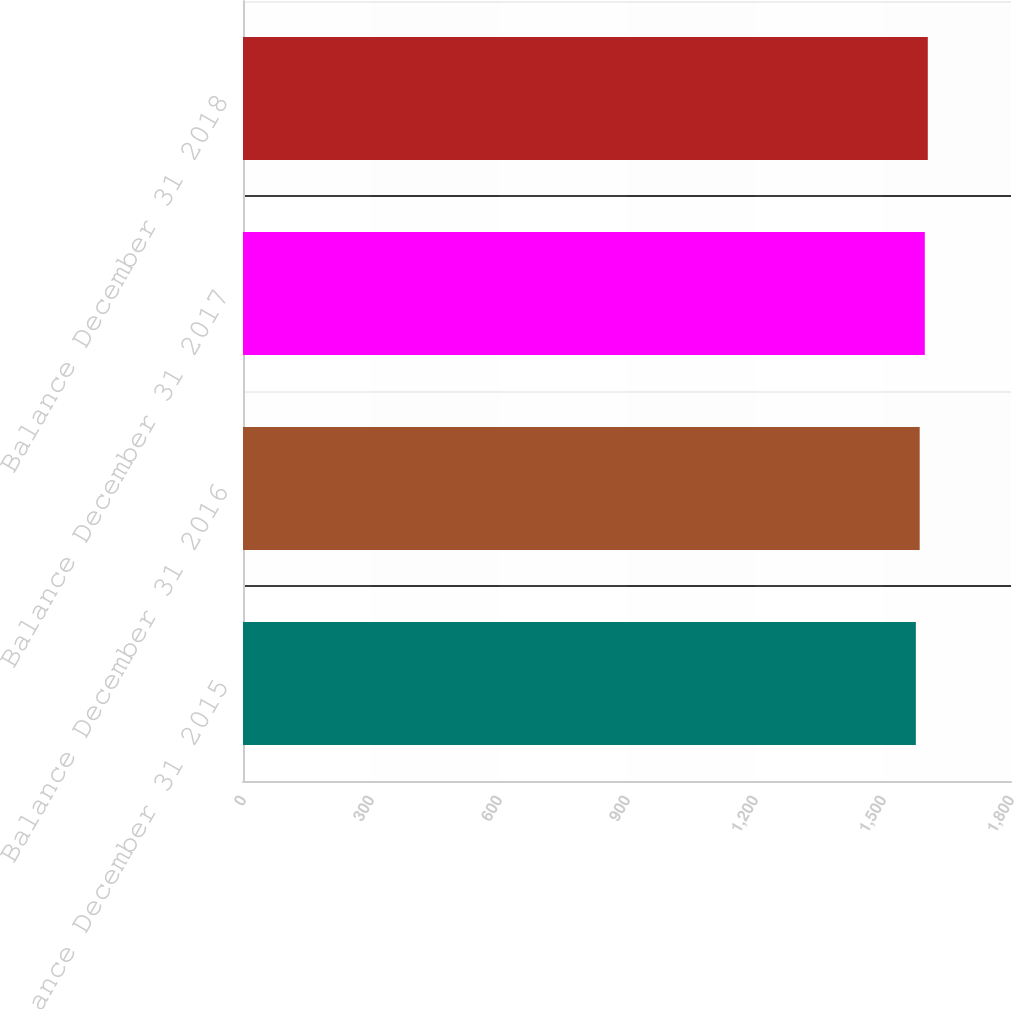<chart> <loc_0><loc_0><loc_500><loc_500><bar_chart><fcel>Balance December 31 2015<fcel>Balance December 31 2016<fcel>Balance December 31 2017<fcel>Balance December 31 2018<nl><fcel>1577<fcel>1586<fcel>1598<fcel>1605<nl></chart> 